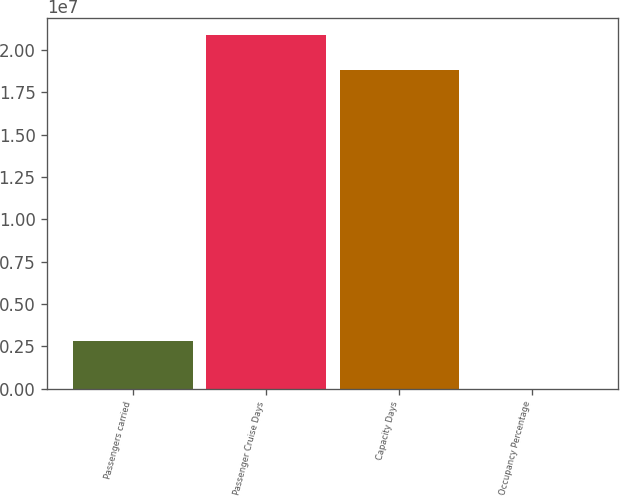Convert chart. <chart><loc_0><loc_0><loc_500><loc_500><bar_chart><fcel>Passengers carried<fcel>Passenger Cruise Days<fcel>Capacity Days<fcel>Occupancy Percentage<nl><fcel>2.7951e+06<fcel>2.08693e+07<fcel>1.88417e+07<fcel>107.6<nl></chart> 